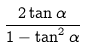Convert formula to latex. <formula><loc_0><loc_0><loc_500><loc_500>\frac { 2 \tan \alpha } { 1 - \tan ^ { 2 } \alpha }</formula> 